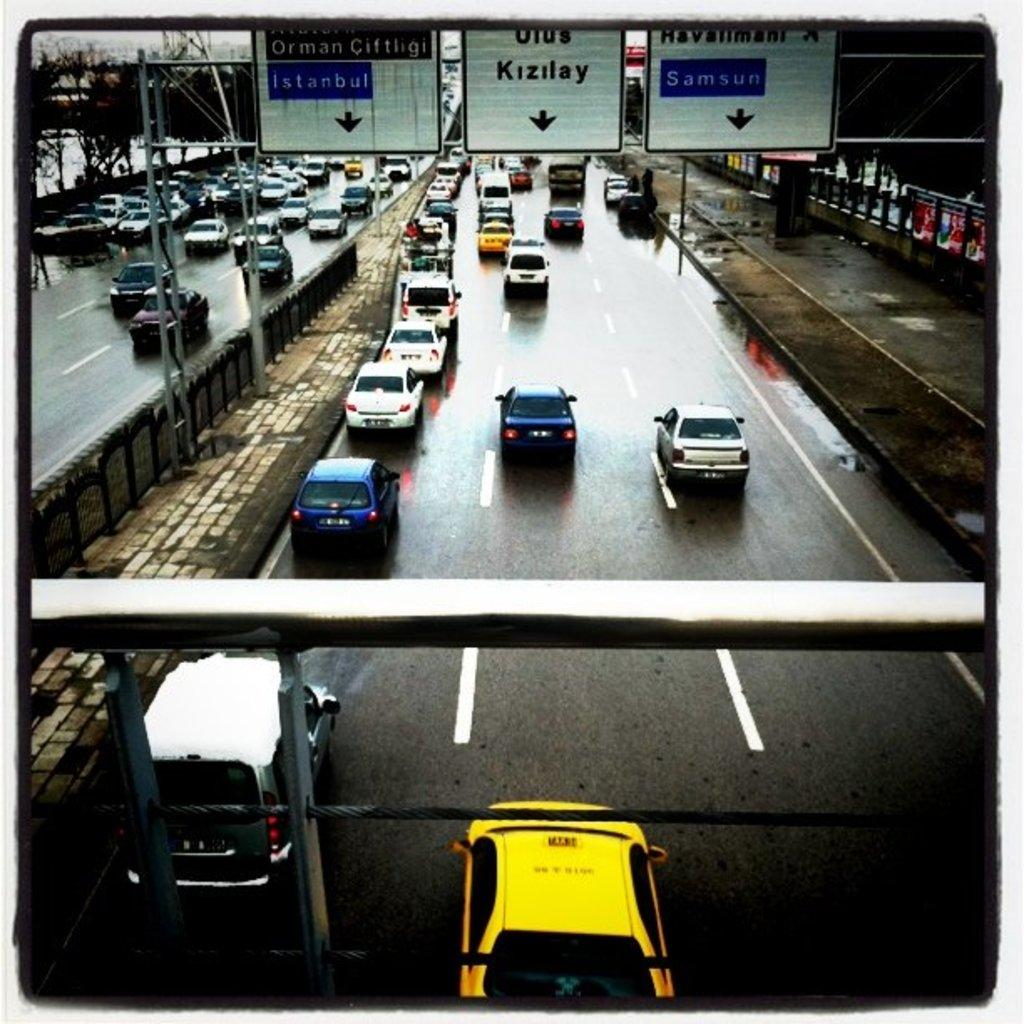<image>
Write a terse but informative summary of the picture. The busy highway has a lane for Istanbul and one for Samsun. 